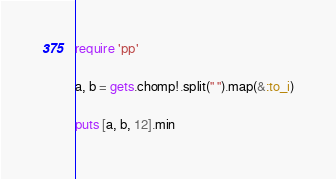Convert code to text. <code><loc_0><loc_0><loc_500><loc_500><_Ruby_>require 'pp'

a, b = gets.chomp!.split(" ").map(&:to_i)

puts [a, b, 12].min
</code> 